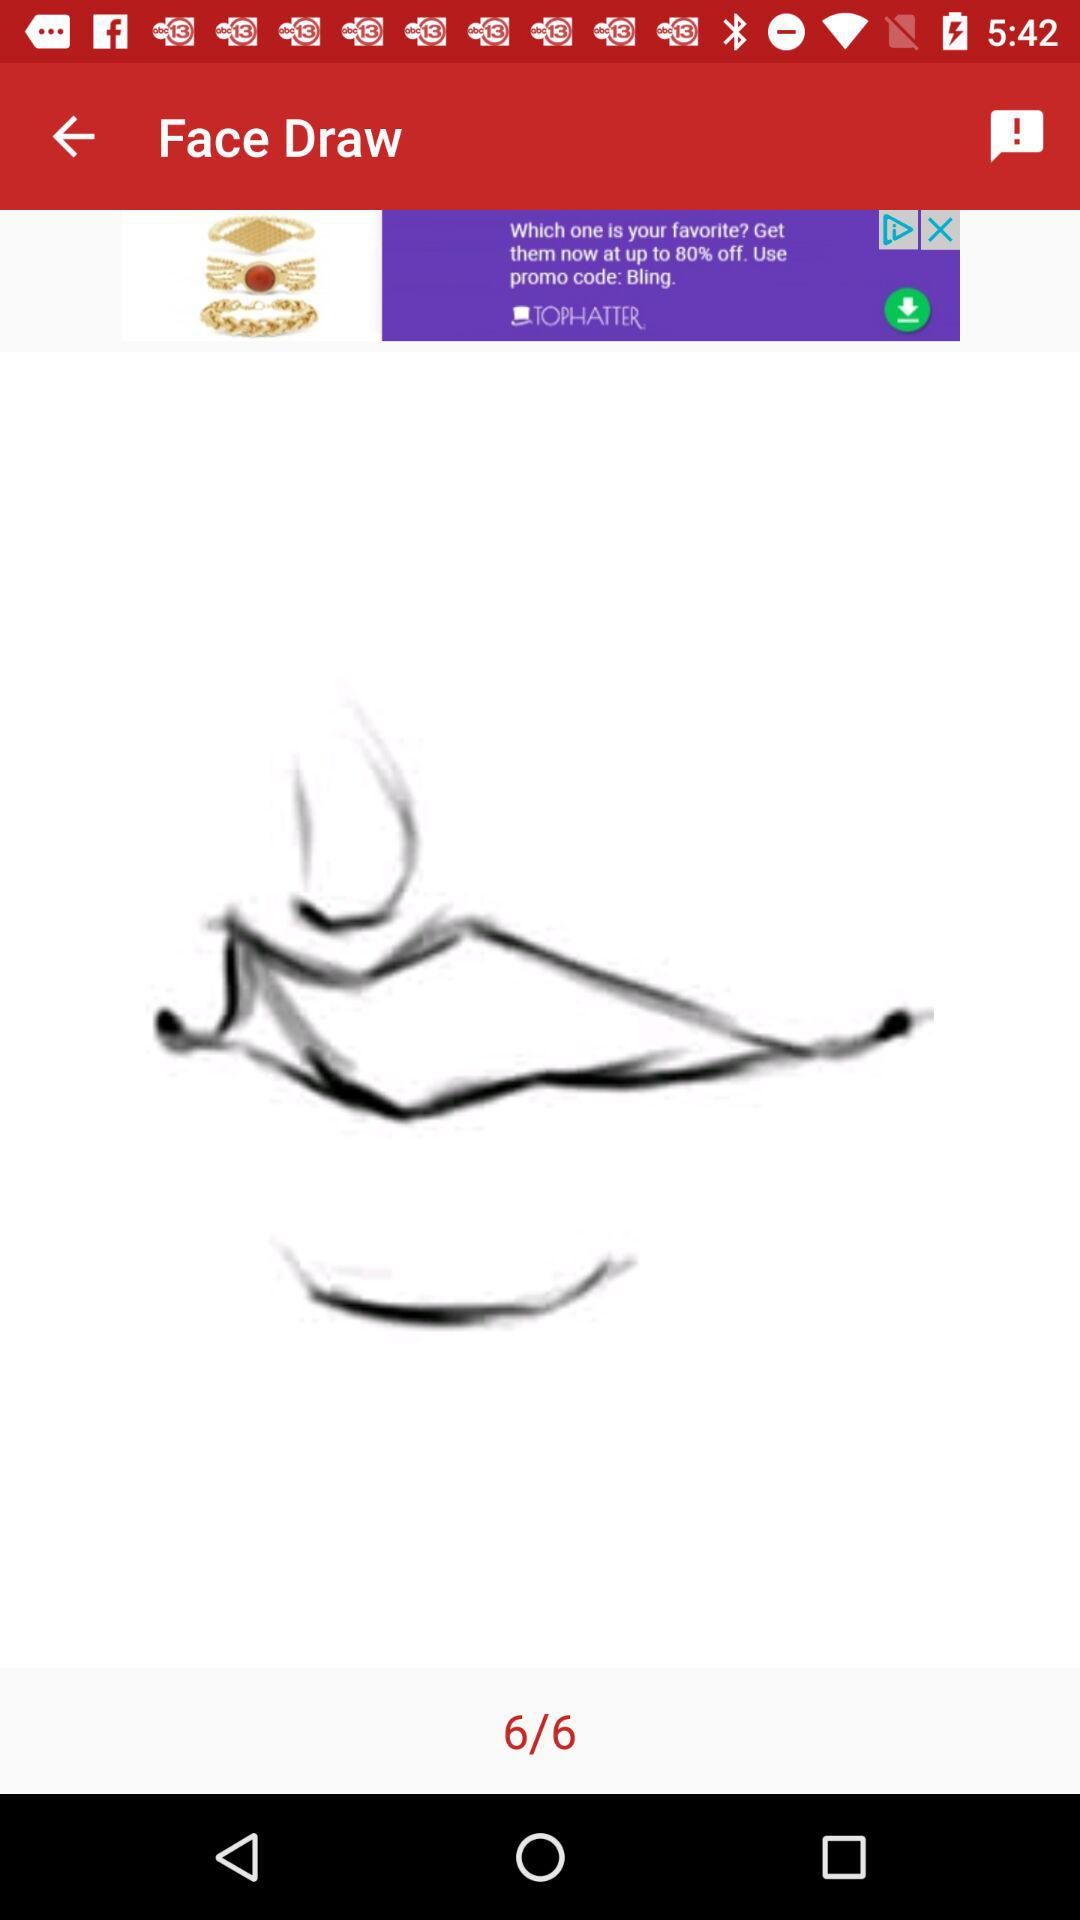How many pages in total are there? There are 6 pages in total. 